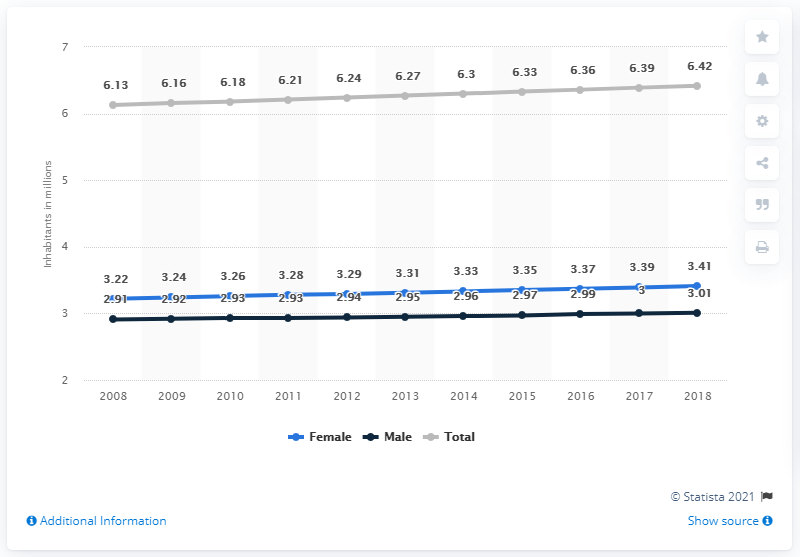Point out several critical features in this image. In 2018, there were approximately 3.41 million women living in El Salvador. The male population has been above 3 million for a number of years. The total amount reached its peak in 2018. In 2018, the estimated number of men living in El Salvador was 3.01 million. In 2018, the population of El Salvador was estimated to be 6.42 million people. 